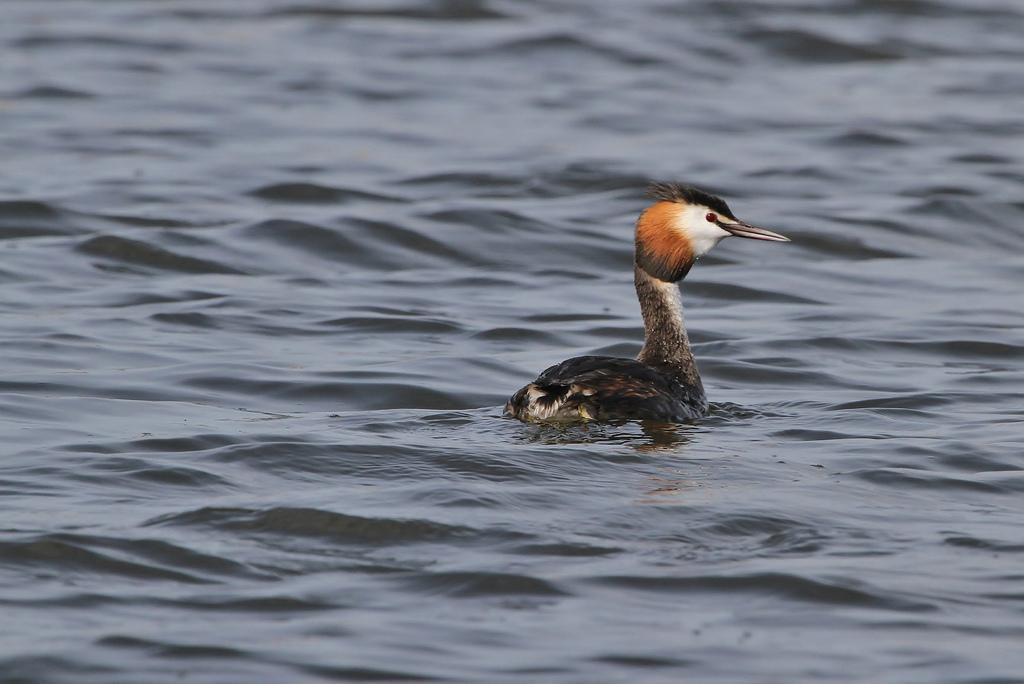What type of animal is in the image? There is a bird in the image. Where is the bird located? The bird is in the water. What colors can be seen on the bird? The bird has black, orange, and white colors. How many steps can be seen in the image? There are no steps present in the image; it features a bird in the water. What type of waves can be seen in the image? There are no waves present in the image; it features a bird in the water. 